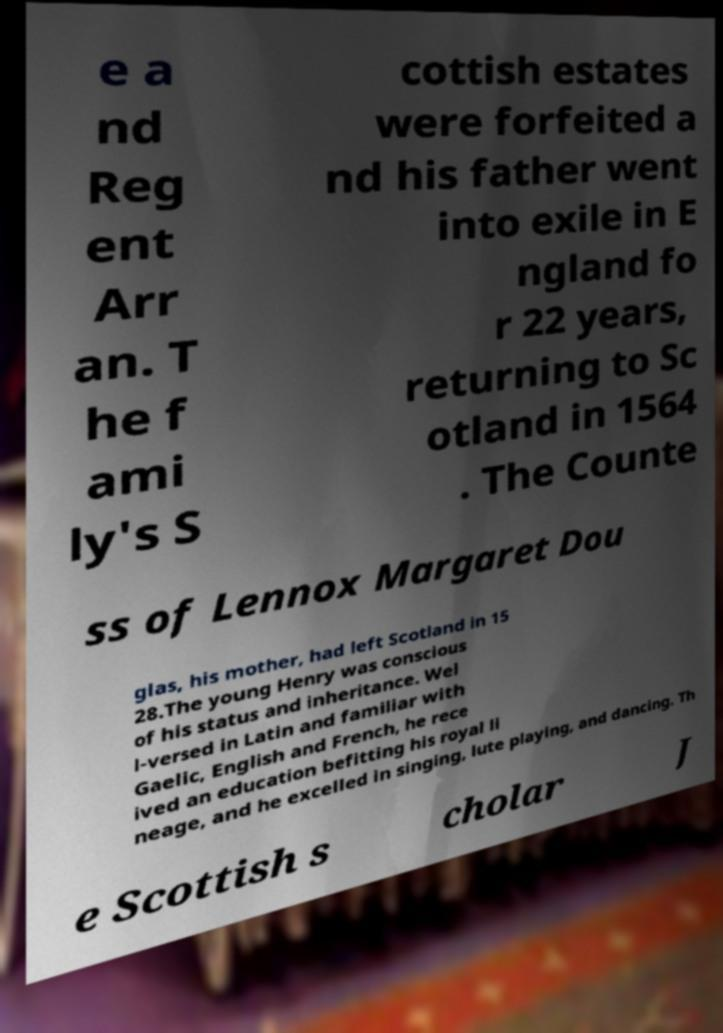Please identify and transcribe the text found in this image. e a nd Reg ent Arr an. T he f ami ly's S cottish estates were forfeited a nd his father went into exile in E ngland fo r 22 years, returning to Sc otland in 1564 . The Counte ss of Lennox Margaret Dou glas, his mother, had left Scotland in 15 28.The young Henry was conscious of his status and inheritance. Wel l-versed in Latin and familiar with Gaelic, English and French, he rece ived an education befitting his royal li neage, and he excelled in singing, lute playing, and dancing. Th e Scottish s cholar J 